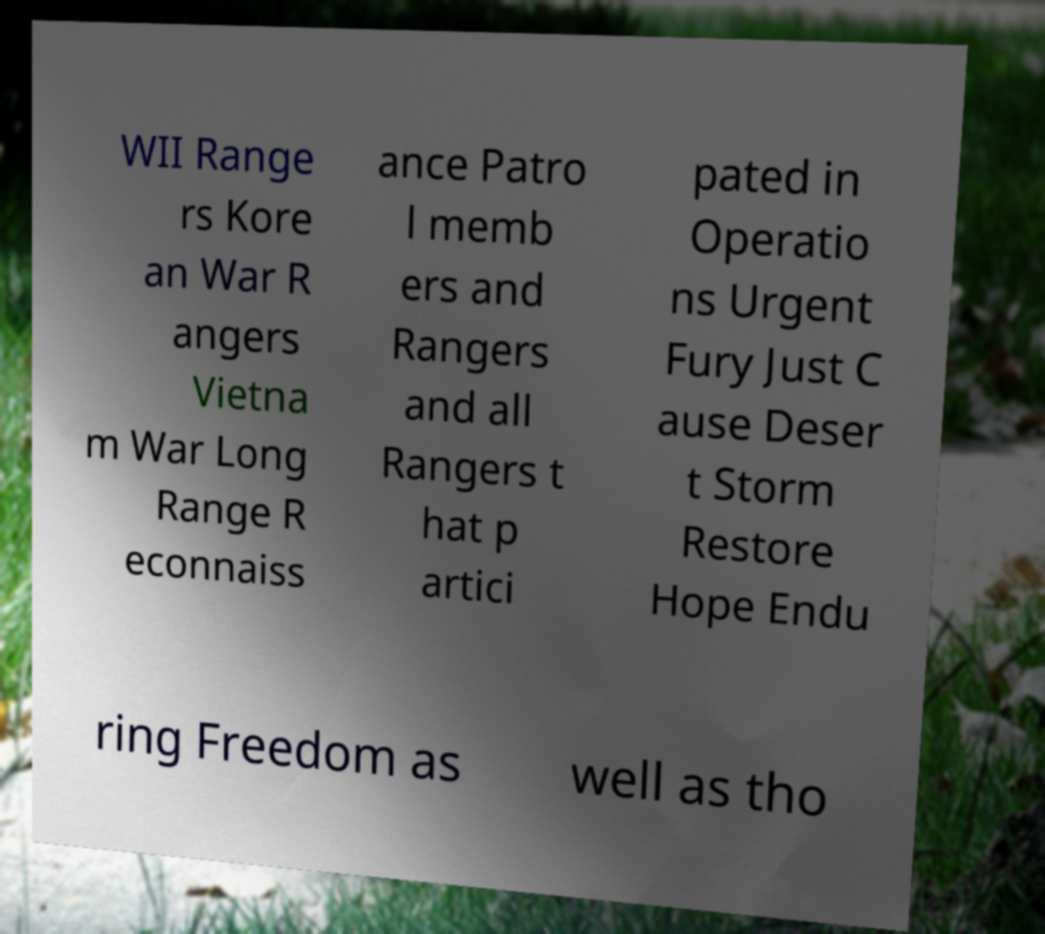There's text embedded in this image that I need extracted. Can you transcribe it verbatim? WII Range rs Kore an War R angers Vietna m War Long Range R econnaiss ance Patro l memb ers and Rangers and all Rangers t hat p artici pated in Operatio ns Urgent Fury Just C ause Deser t Storm Restore Hope Endu ring Freedom as well as tho 